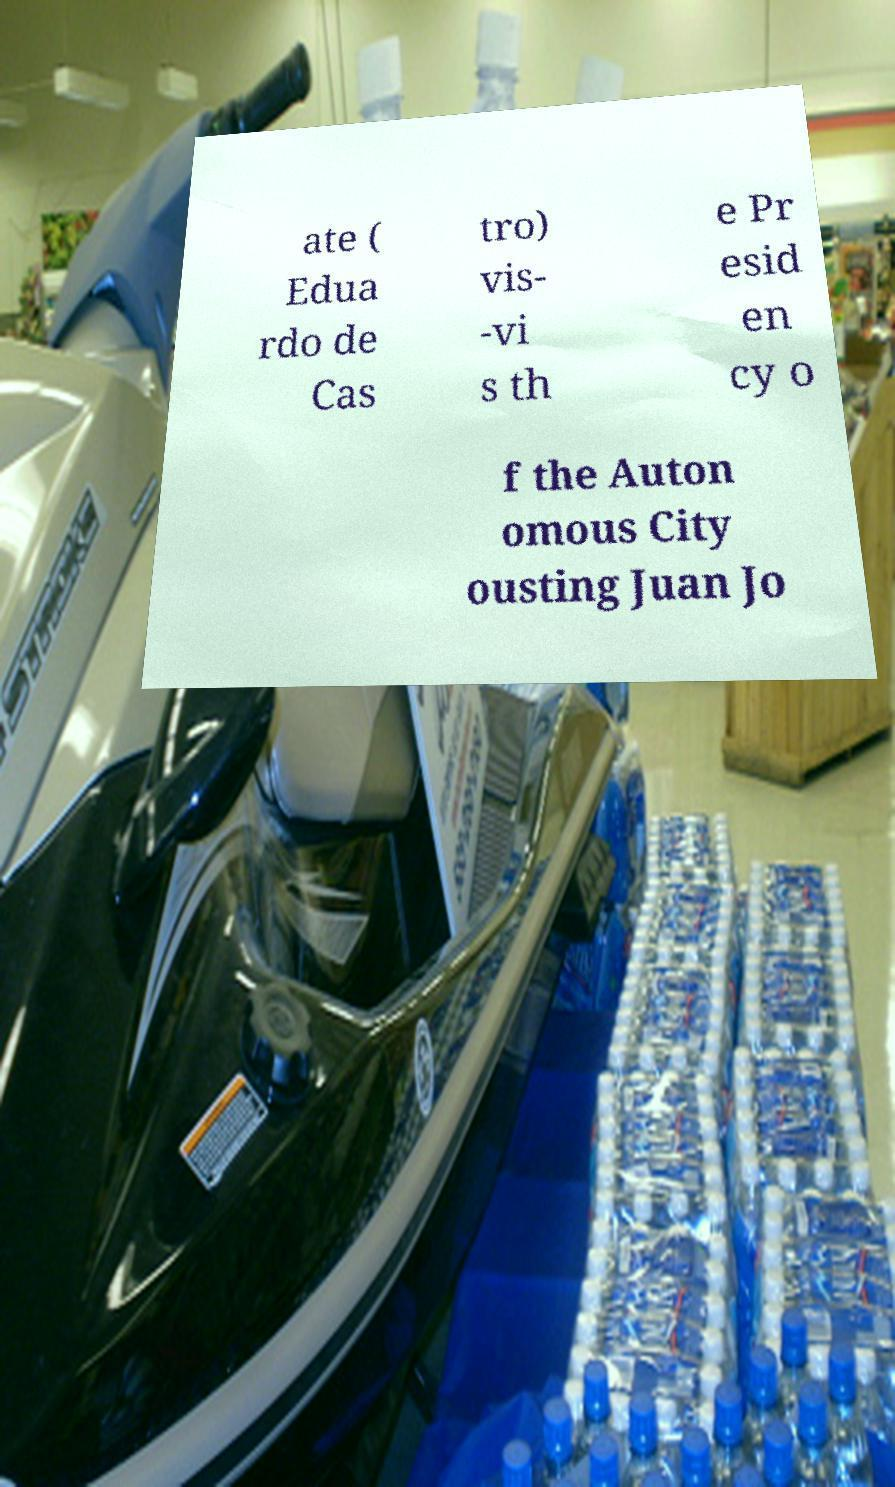What messages or text are displayed in this image? I need them in a readable, typed format. ate ( Edua rdo de Cas tro) vis- -vi s th e Pr esid en cy o f the Auton omous City ousting Juan Jo 